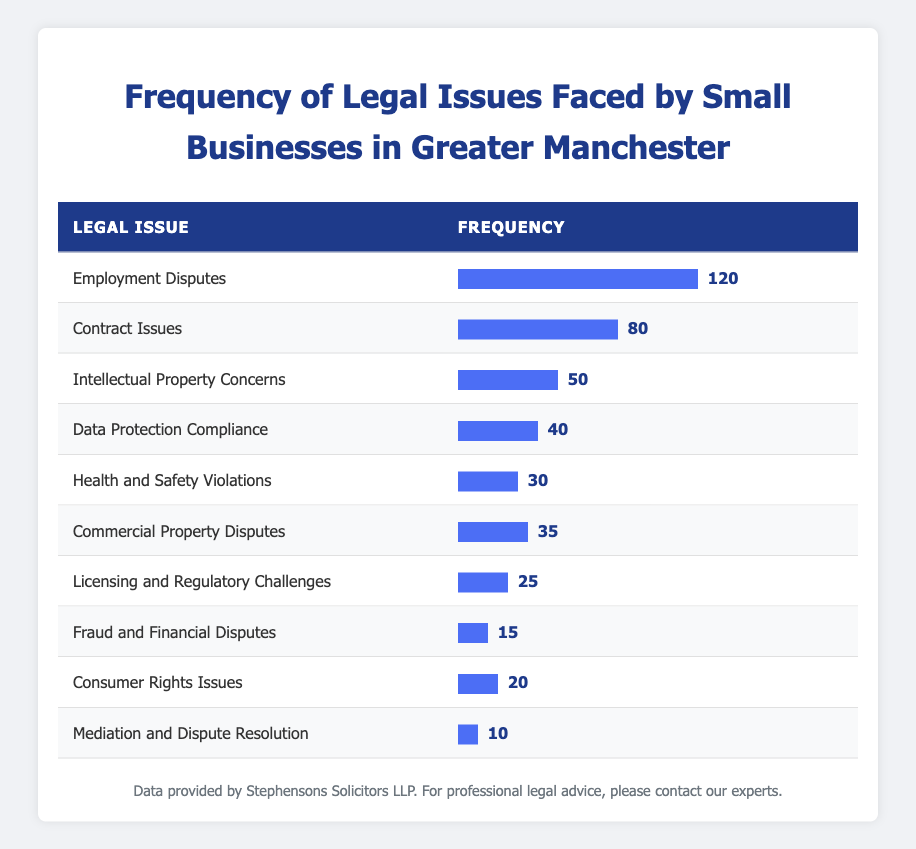What is the frequency of Employment Disputes? The table explicitly lists "Employment Disputes" with a corresponding frequency of 120.
Answer: 120 How many frequencies are higher than 30? From the table, the legal issues with frequencies higher than 30 are: Employment Disputes (120), Contract Issues (80), Intellectual Property Concerns (50), Data Protection Compliance (40), Health and Safety Violations (30), and Commercial Property Disputes (35). This totals to six legal issues.
Answer: 6 What is the difference in frequency between Contract Issues and Licensing and Regulatory Challenges? The frequency for Contract Issues is 80 and for Licensing and Regulatory Challenges, it is 25. Subtracting gives 80 - 25 = 55.
Answer: 55 Is the frequency of Fraud and Financial Disputes less than 20? The table shows Fraud and Financial Disputes has a frequency of 15, which is indeed less than 20.
Answer: Yes What is the total frequency of all legal issues listed in the table? To find the total frequency, add up all the frequencies: 120 + 80 + 50 + 40 + 30 + 35 + 25 + 15 + 20 + 10 = 405.
Answer: 405 What is the average frequency of the legal issues listed? There are 10 legal issues with a total frequency of 405. To find the average, divide the total by the number of issues: 405 / 10 = 40.5.
Answer: 40.5 Which legal issue had the highest frequency and what was that frequency? The table indicates that "Employment Disputes" has the highest frequency at 120.
Answer: Employment Disputes, 120 Are there more legal issues with frequencies above 40 than below 40? The legal issues with frequencies above 40 are: Employment Disputes (120), Contract Issues (80), Intellectual Property Concerns (50), and Data Protection Compliance (40), totaling four. Those below 40 are: Health and Safety Violations (30), Commercial Property Disputes (35), Licensing and Regulatory Challenges (25), Fraud and Financial Disputes (15), Consumer Rights Issues (20), and Mediation and Dispute Resolution (10), totaling six. Hence, there are more below 40.
Answer: No 